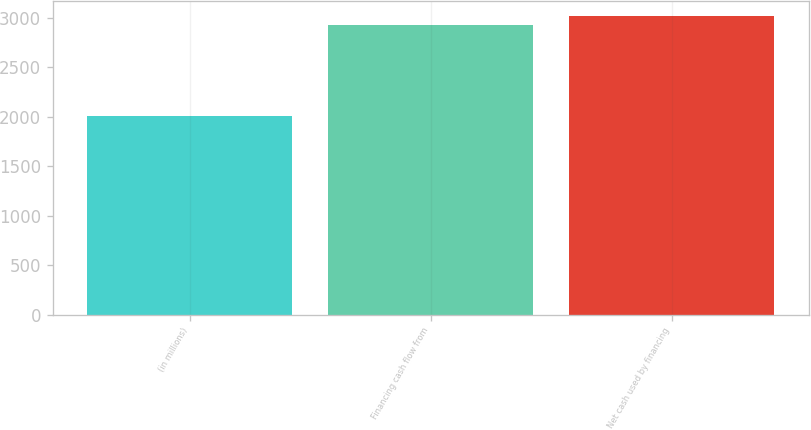Convert chart to OTSL. <chart><loc_0><loc_0><loc_500><loc_500><bar_chart><fcel>(in millions)<fcel>Financing cash flow from<fcel>Net cash used by financing<nl><fcel>2013<fcel>2933<fcel>3025<nl></chart> 